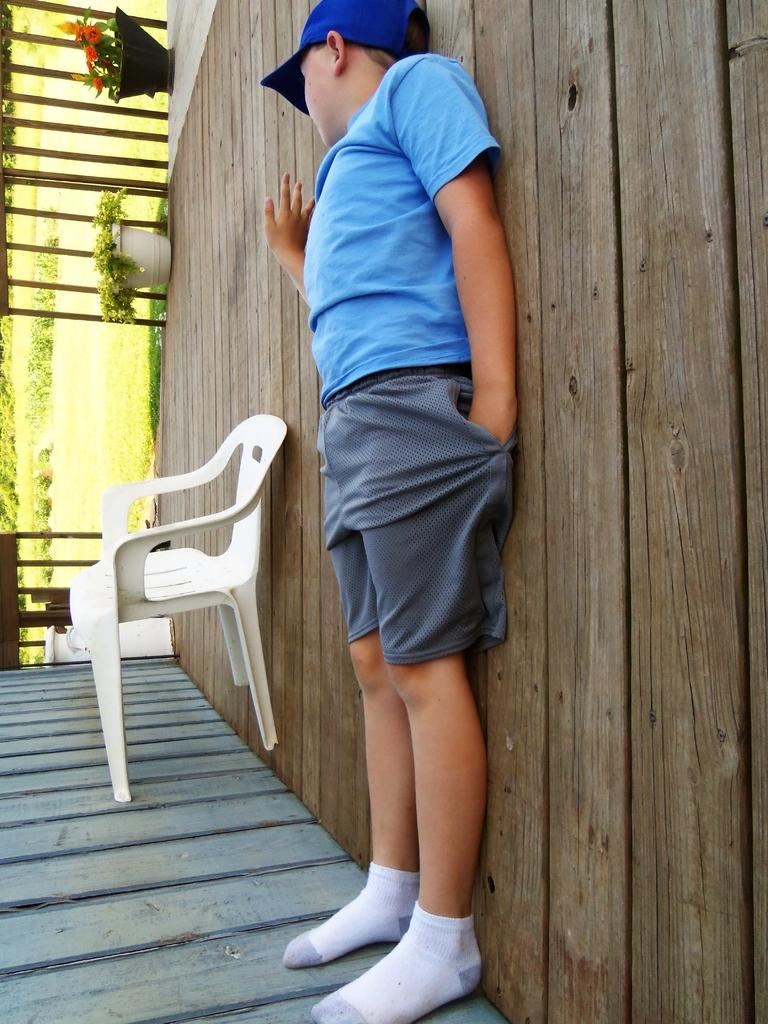Who is present in the image? There is a boy in the image. What is the boy wearing? The boy is wearing a blue shirt and ash-colored shorts. What is the boy's posture in the image? The boy is standing. What other objects can be seen in the image? There is a chair and two plants in the image. Where is the sink located in the image? There is no sink present in the image. What type of glove is the boy wearing in the image? The boy is not wearing any gloves in the image. 